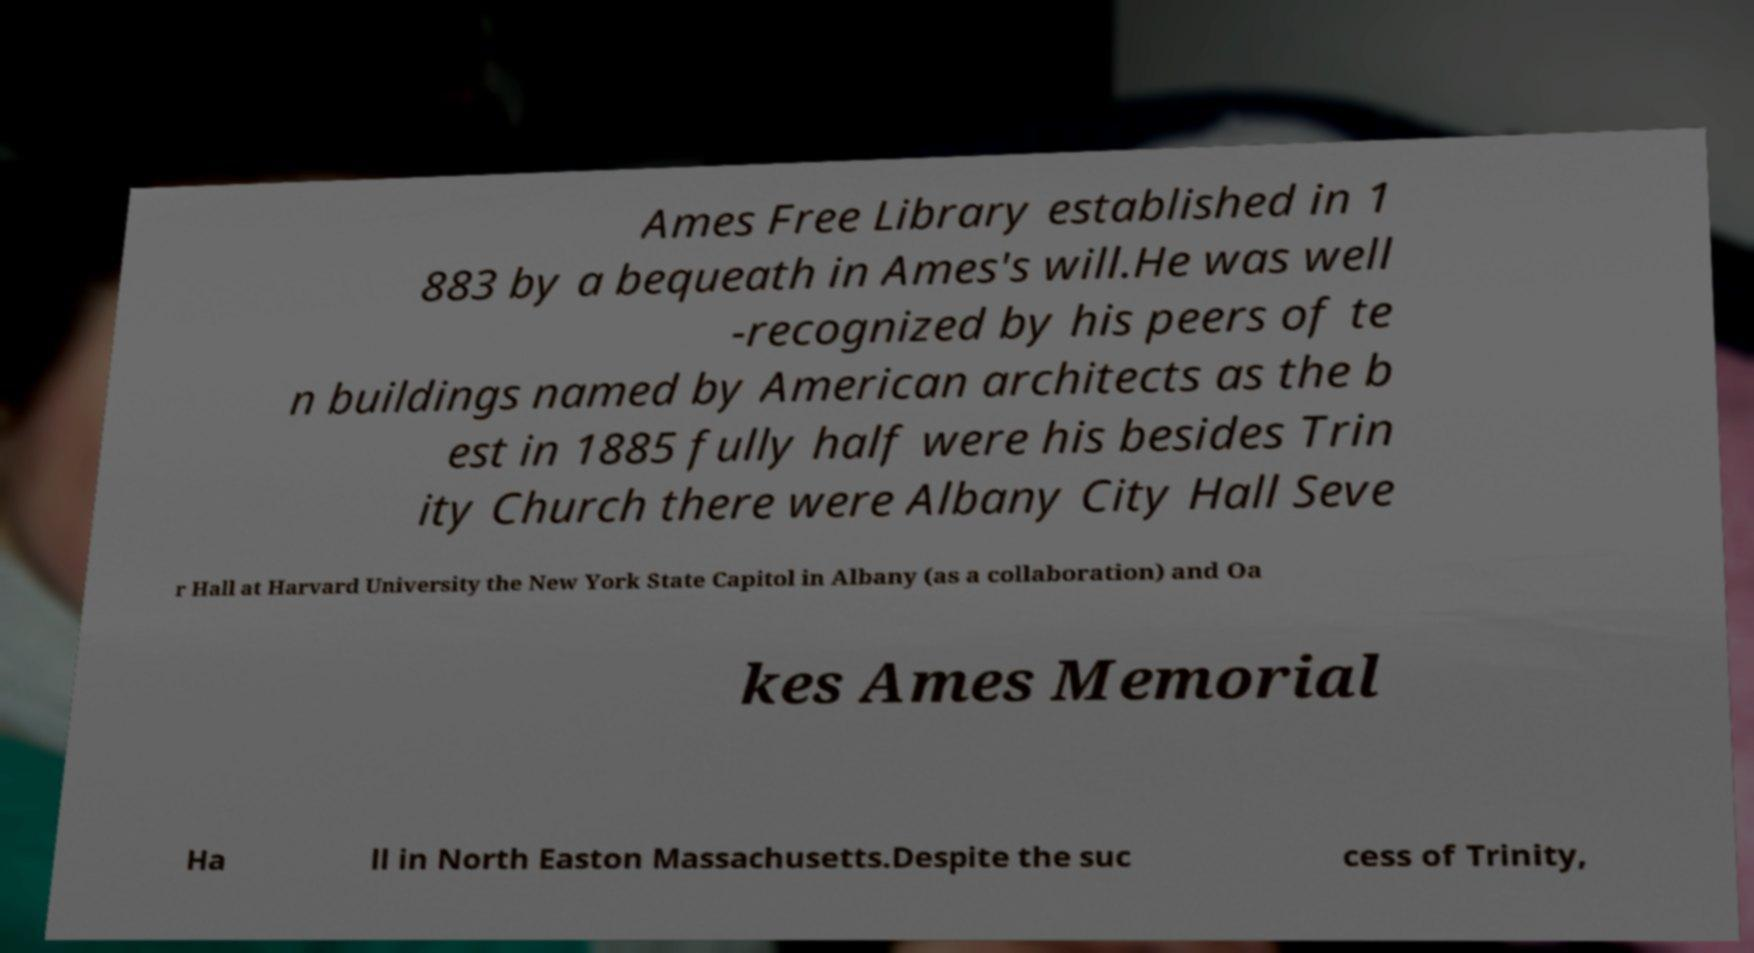Please identify and transcribe the text found in this image. Ames Free Library established in 1 883 by a bequeath in Ames's will.He was well -recognized by his peers of te n buildings named by American architects as the b est in 1885 fully half were his besides Trin ity Church there were Albany City Hall Seve r Hall at Harvard University the New York State Capitol in Albany (as a collaboration) and Oa kes Ames Memorial Ha ll in North Easton Massachusetts.Despite the suc cess of Trinity, 